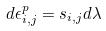Convert formula to latex. <formula><loc_0><loc_0><loc_500><loc_500>d \epsilon _ { i , j } ^ { p } = s _ { i , j } d \lambda</formula> 